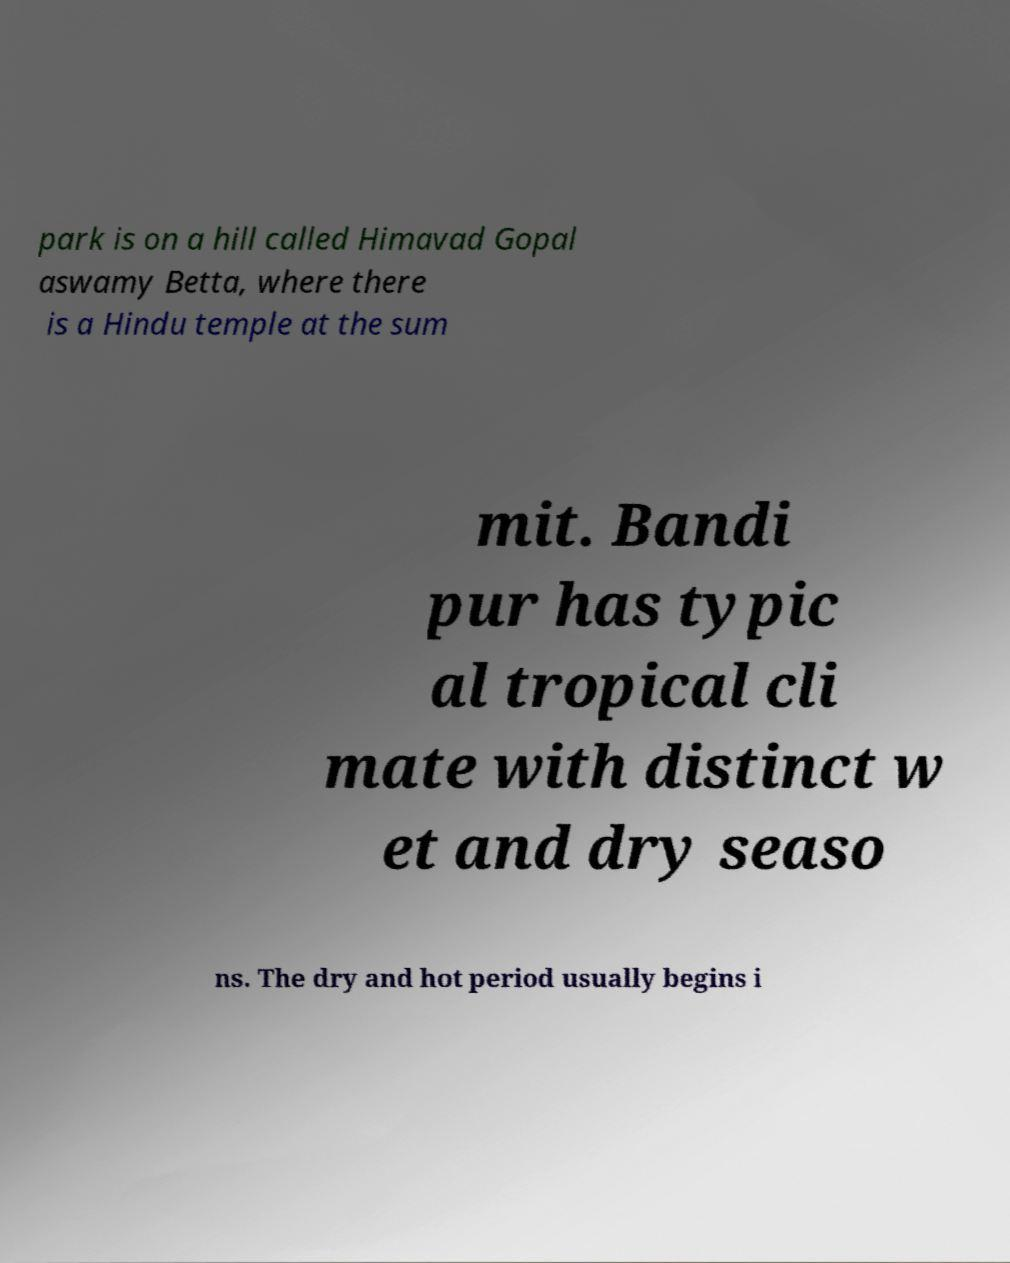Please read and relay the text visible in this image. What does it say? park is on a hill called Himavad Gopal aswamy Betta, where there is a Hindu temple at the sum mit. Bandi pur has typic al tropical cli mate with distinct w et and dry seaso ns. The dry and hot period usually begins i 